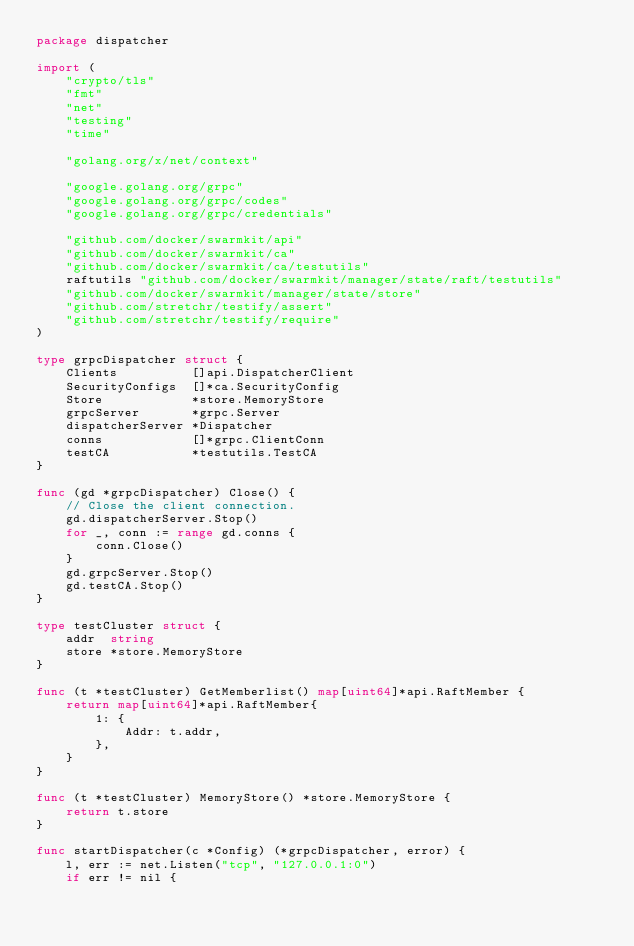Convert code to text. <code><loc_0><loc_0><loc_500><loc_500><_Go_>package dispatcher

import (
	"crypto/tls"
	"fmt"
	"net"
	"testing"
	"time"

	"golang.org/x/net/context"

	"google.golang.org/grpc"
	"google.golang.org/grpc/codes"
	"google.golang.org/grpc/credentials"

	"github.com/docker/swarmkit/api"
	"github.com/docker/swarmkit/ca"
	"github.com/docker/swarmkit/ca/testutils"
	raftutils "github.com/docker/swarmkit/manager/state/raft/testutils"
	"github.com/docker/swarmkit/manager/state/store"
	"github.com/stretchr/testify/assert"
	"github.com/stretchr/testify/require"
)

type grpcDispatcher struct {
	Clients          []api.DispatcherClient
	SecurityConfigs  []*ca.SecurityConfig
	Store            *store.MemoryStore
	grpcServer       *grpc.Server
	dispatcherServer *Dispatcher
	conns            []*grpc.ClientConn
	testCA           *testutils.TestCA
}

func (gd *grpcDispatcher) Close() {
	// Close the client connection.
	gd.dispatcherServer.Stop()
	for _, conn := range gd.conns {
		conn.Close()
	}
	gd.grpcServer.Stop()
	gd.testCA.Stop()
}

type testCluster struct {
	addr  string
	store *store.MemoryStore
}

func (t *testCluster) GetMemberlist() map[uint64]*api.RaftMember {
	return map[uint64]*api.RaftMember{
		1: {
			Addr: t.addr,
		},
	}
}

func (t *testCluster) MemoryStore() *store.MemoryStore {
	return t.store
}

func startDispatcher(c *Config) (*grpcDispatcher, error) {
	l, err := net.Listen("tcp", "127.0.0.1:0")
	if err != nil {</code> 